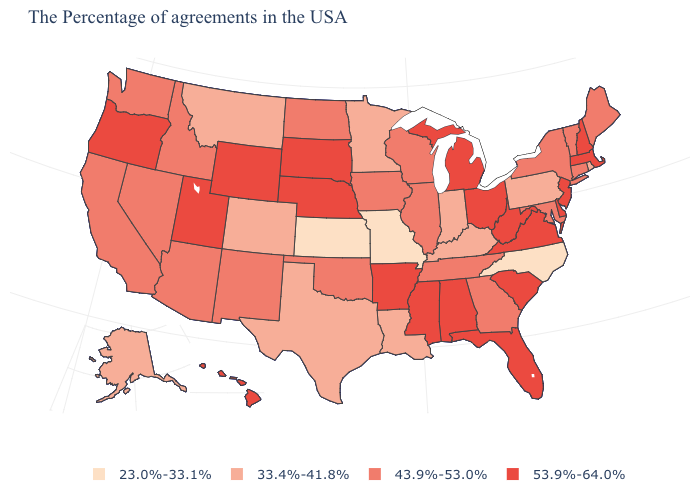What is the lowest value in states that border Wisconsin?
Give a very brief answer. 33.4%-41.8%. Among the states that border Nevada , does Arizona have the lowest value?
Answer briefly. Yes. Name the states that have a value in the range 33.4%-41.8%?
Short answer required. Rhode Island, Pennsylvania, Kentucky, Indiana, Louisiana, Minnesota, Texas, Colorado, Montana, Alaska. What is the value of Idaho?
Short answer required. 43.9%-53.0%. What is the value of Mississippi?
Give a very brief answer. 53.9%-64.0%. Among the states that border Wyoming , does Nebraska have the lowest value?
Give a very brief answer. No. Among the states that border Colorado , which have the highest value?
Keep it brief. Nebraska, Wyoming, Utah. What is the value of Georgia?
Short answer required. 43.9%-53.0%. Does Kansas have the lowest value in the USA?
Answer briefly. Yes. What is the highest value in states that border Oklahoma?
Write a very short answer. 53.9%-64.0%. What is the value of New York?
Give a very brief answer. 43.9%-53.0%. What is the lowest value in the USA?
Quick response, please. 23.0%-33.1%. What is the value of Massachusetts?
Keep it brief. 53.9%-64.0%. Which states have the lowest value in the USA?
Quick response, please. North Carolina, Missouri, Kansas. Which states have the lowest value in the USA?
Give a very brief answer. North Carolina, Missouri, Kansas. 